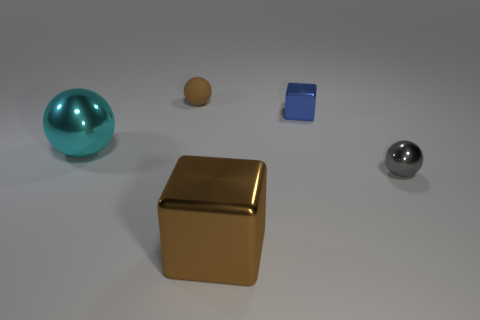Subtract all brown cubes. Subtract all red cylinders. How many cubes are left? 1 Add 5 gray metal blocks. How many objects exist? 10 Subtract all cubes. How many objects are left? 3 Add 2 large cyan rubber spheres. How many large cyan rubber spheres exist? 2 Subtract 0 yellow blocks. How many objects are left? 5 Subtract all small brown matte spheres. Subtract all purple matte cylinders. How many objects are left? 4 Add 2 large brown metallic cubes. How many large brown metallic cubes are left? 3 